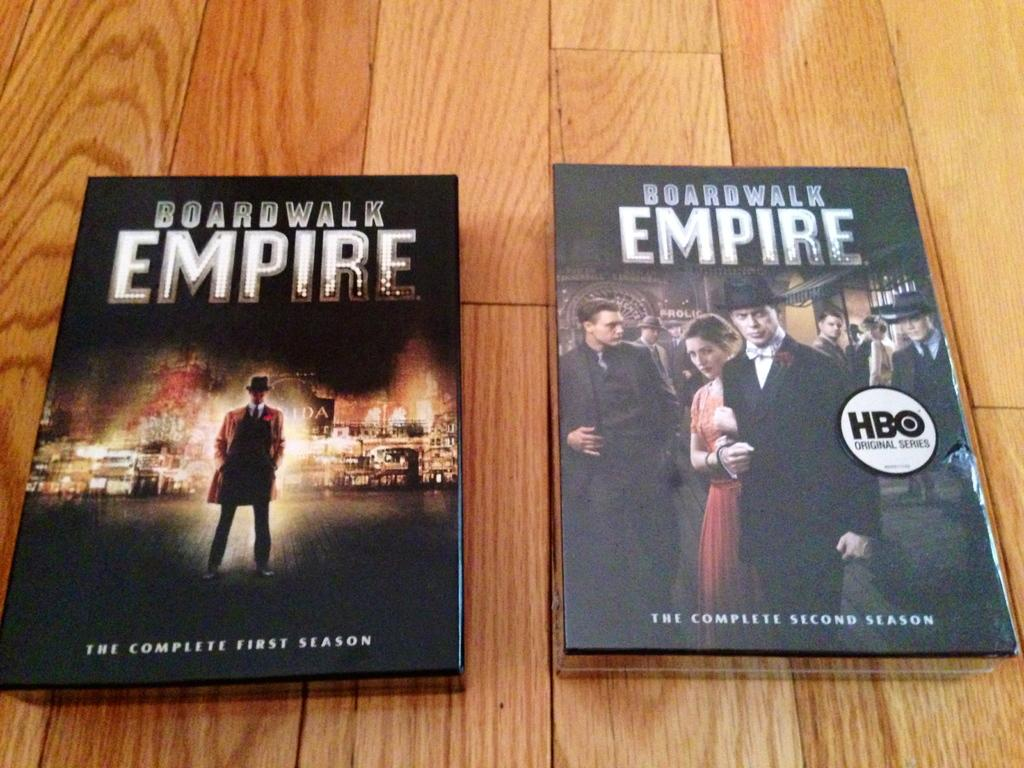<image>
Create a compact narrative representing the image presented. Two DVD cases for the show Boardwalk Empire. 